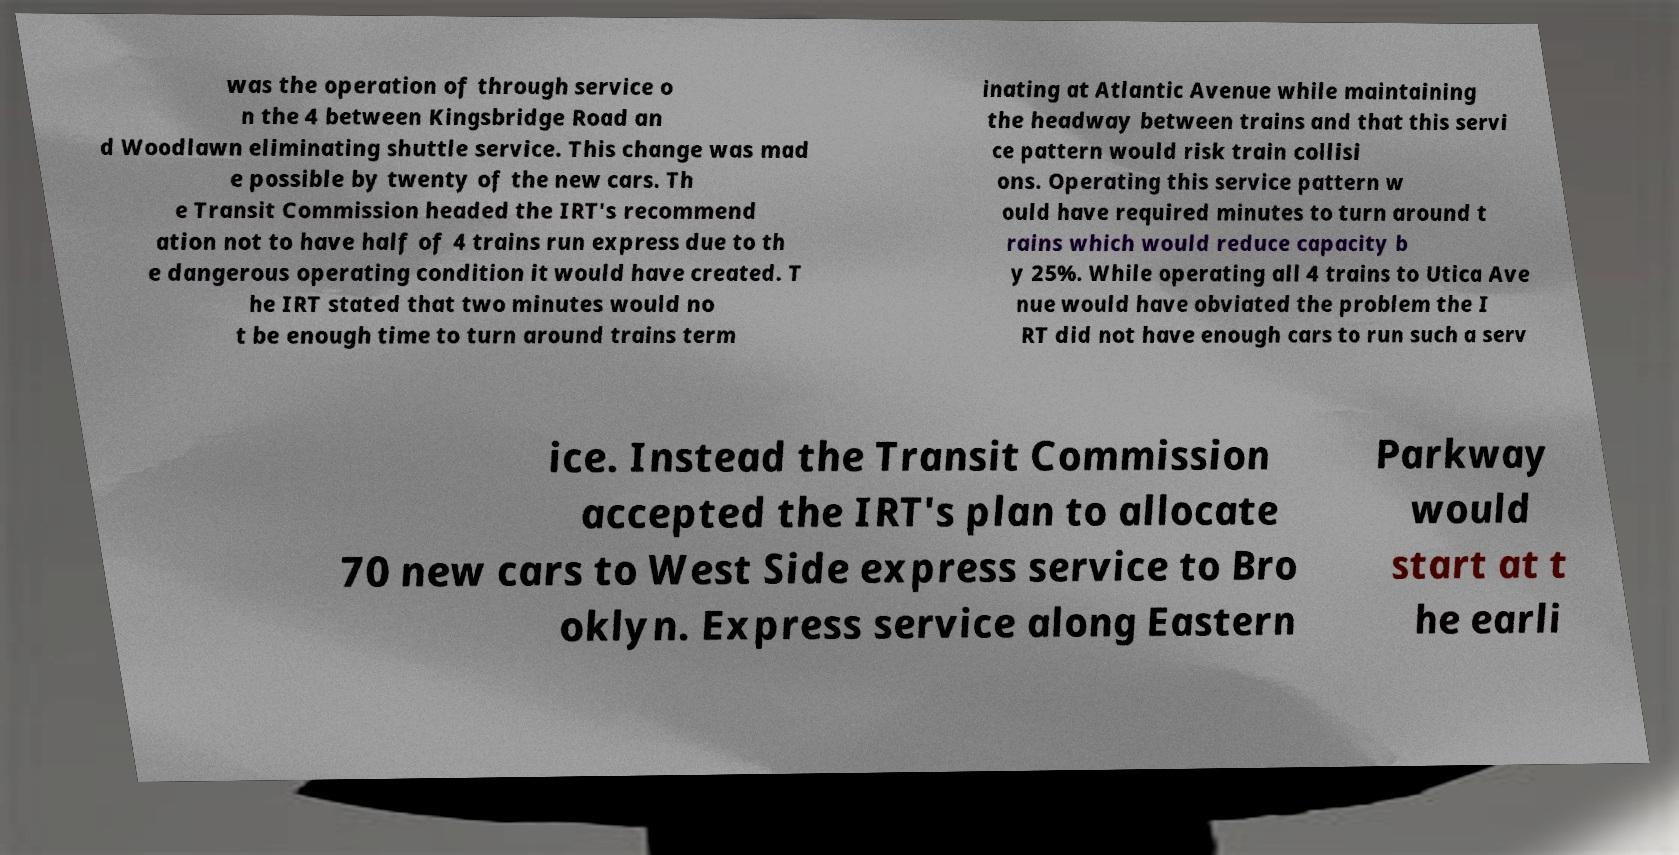There's text embedded in this image that I need extracted. Can you transcribe it verbatim? was the operation of through service o n the 4 between Kingsbridge Road an d Woodlawn eliminating shuttle service. This change was mad e possible by twenty of the new cars. Th e Transit Commission headed the IRT's recommend ation not to have half of 4 trains run express due to th e dangerous operating condition it would have created. T he IRT stated that two minutes would no t be enough time to turn around trains term inating at Atlantic Avenue while maintaining the headway between trains and that this servi ce pattern would risk train collisi ons. Operating this service pattern w ould have required minutes to turn around t rains which would reduce capacity b y 25%. While operating all 4 trains to Utica Ave nue would have obviated the problem the I RT did not have enough cars to run such a serv ice. Instead the Transit Commission accepted the IRT's plan to allocate 70 new cars to West Side express service to Bro oklyn. Express service along Eastern Parkway would start at t he earli 